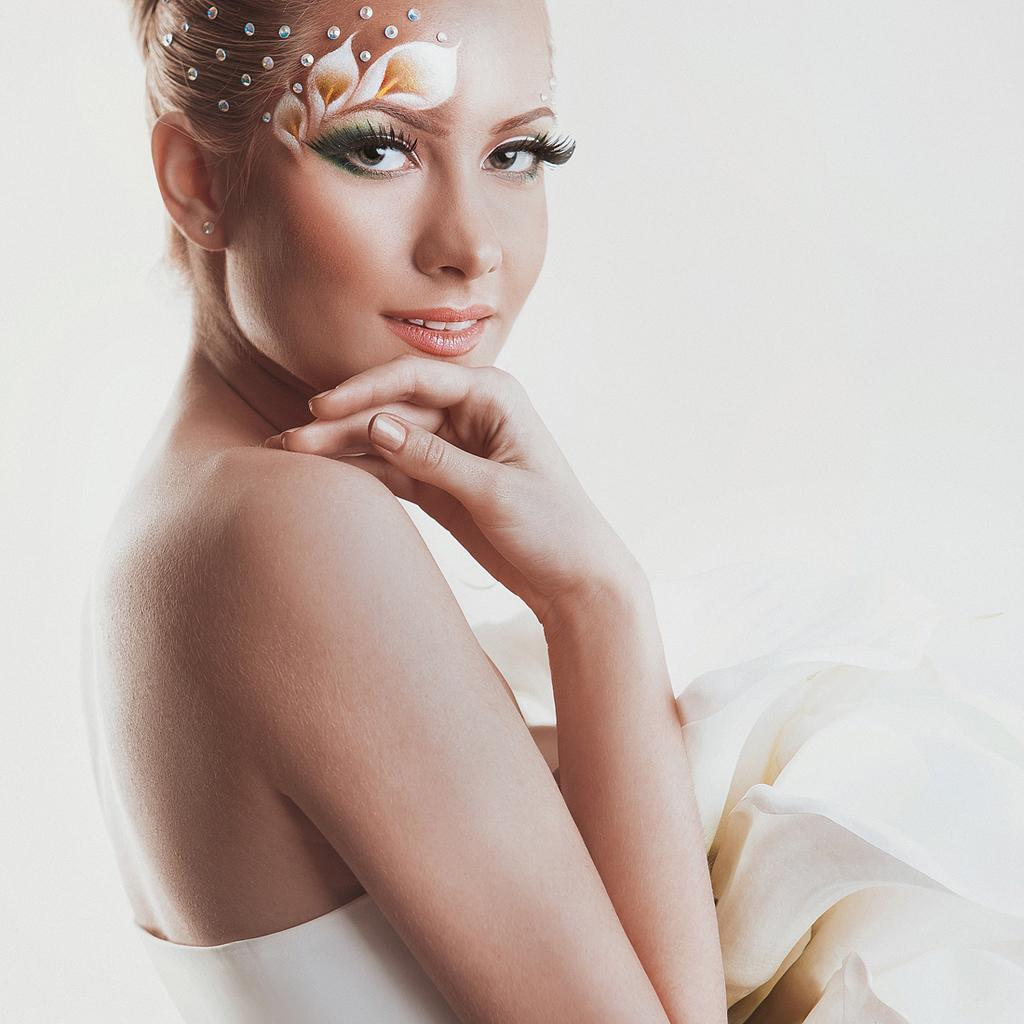How would you summarize this image in a sentence or two? In this picture there is a woman standing in the front, smiling and giving a pose to the camera. Behind there is a white background. 